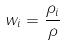Convert formula to latex. <formula><loc_0><loc_0><loc_500><loc_500>w _ { i } = \frac { \rho _ { i } } { \rho }</formula> 